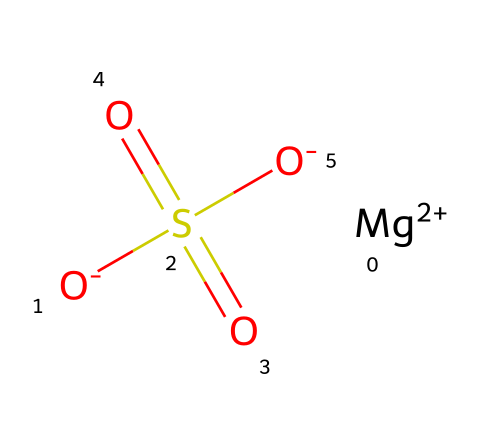What is the chemical formula of magnesium sulfate? The SMILES representation can be translated to its chemical formula. By analyzing the elements present, magnesium (Mg), sulfur (S), and oxygen (O), we deduce the formula is MgSO4.
Answer: MgSO4 How many oxygen atoms are in magnesium sulfate? From the structure, we can count the number of oxygen atoms indicated. There are four oxygen atoms from the sulfate group (O) and one attached to the magnesium ion (O-), totaling four.
Answer: 4 What charge does the magnesium ion carry in this compound? The SMILES representation indicates that the magnesium ion is written as [Mg+2], which shows that it carries a +2 charge.
Answer: +2 Is magnesium sulfate classified as an electrolyte? Magnesium sulfate is commonly known to dissolve in water to yield its respective ions, which is a characteristic of electrolytes. Thus, it is classified as an electrolyte.
Answer: yes What type of bonding is present between magnesium and sulfate? In the provided structure, the bonding between magnesium and sulfate can be inferred as an ionic bond, where the positively charged magnesium ion interacts with the negatively charged sulfate ion.
Answer: ionic What effect does magnesium sulfate have on muscle recovery? Magnesium sulfate is known for its ability to reduce muscle soreness and inflammation, aiding in muscle recovery after exercise. Its use in baths is commonly associated with relaxation.
Answer: reduces soreness What happens to magnesium sulfate when dissolved in water? When magnesium sulfate is dissolved in water, it dissociates into magnesium ions (Mg^2+) and sulfate ions (SO4^2-), which is a characteristic behavior of electrolytes.
Answer: dissociates into ions 